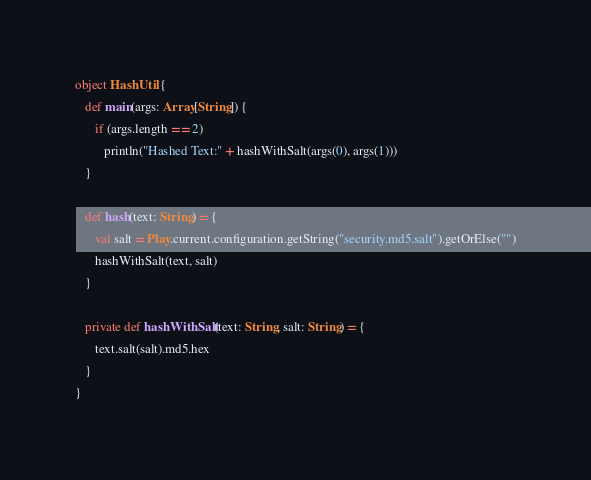<code> <loc_0><loc_0><loc_500><loc_500><_Scala_>
object HashUtil {
   def main(args: Array[String]) {
      if (args.length == 2)
         println("Hashed Text:" + hashWithSalt(args(0), args(1)))
   }

   def hash(text: String) = {
      val salt = Play.current.configuration.getString("security.md5.salt").getOrElse("")
      hashWithSalt(text, salt)
   }

   private def hashWithSalt(text: String, salt: String) = {
      text.salt(salt).md5.hex
   }
}
</code> 